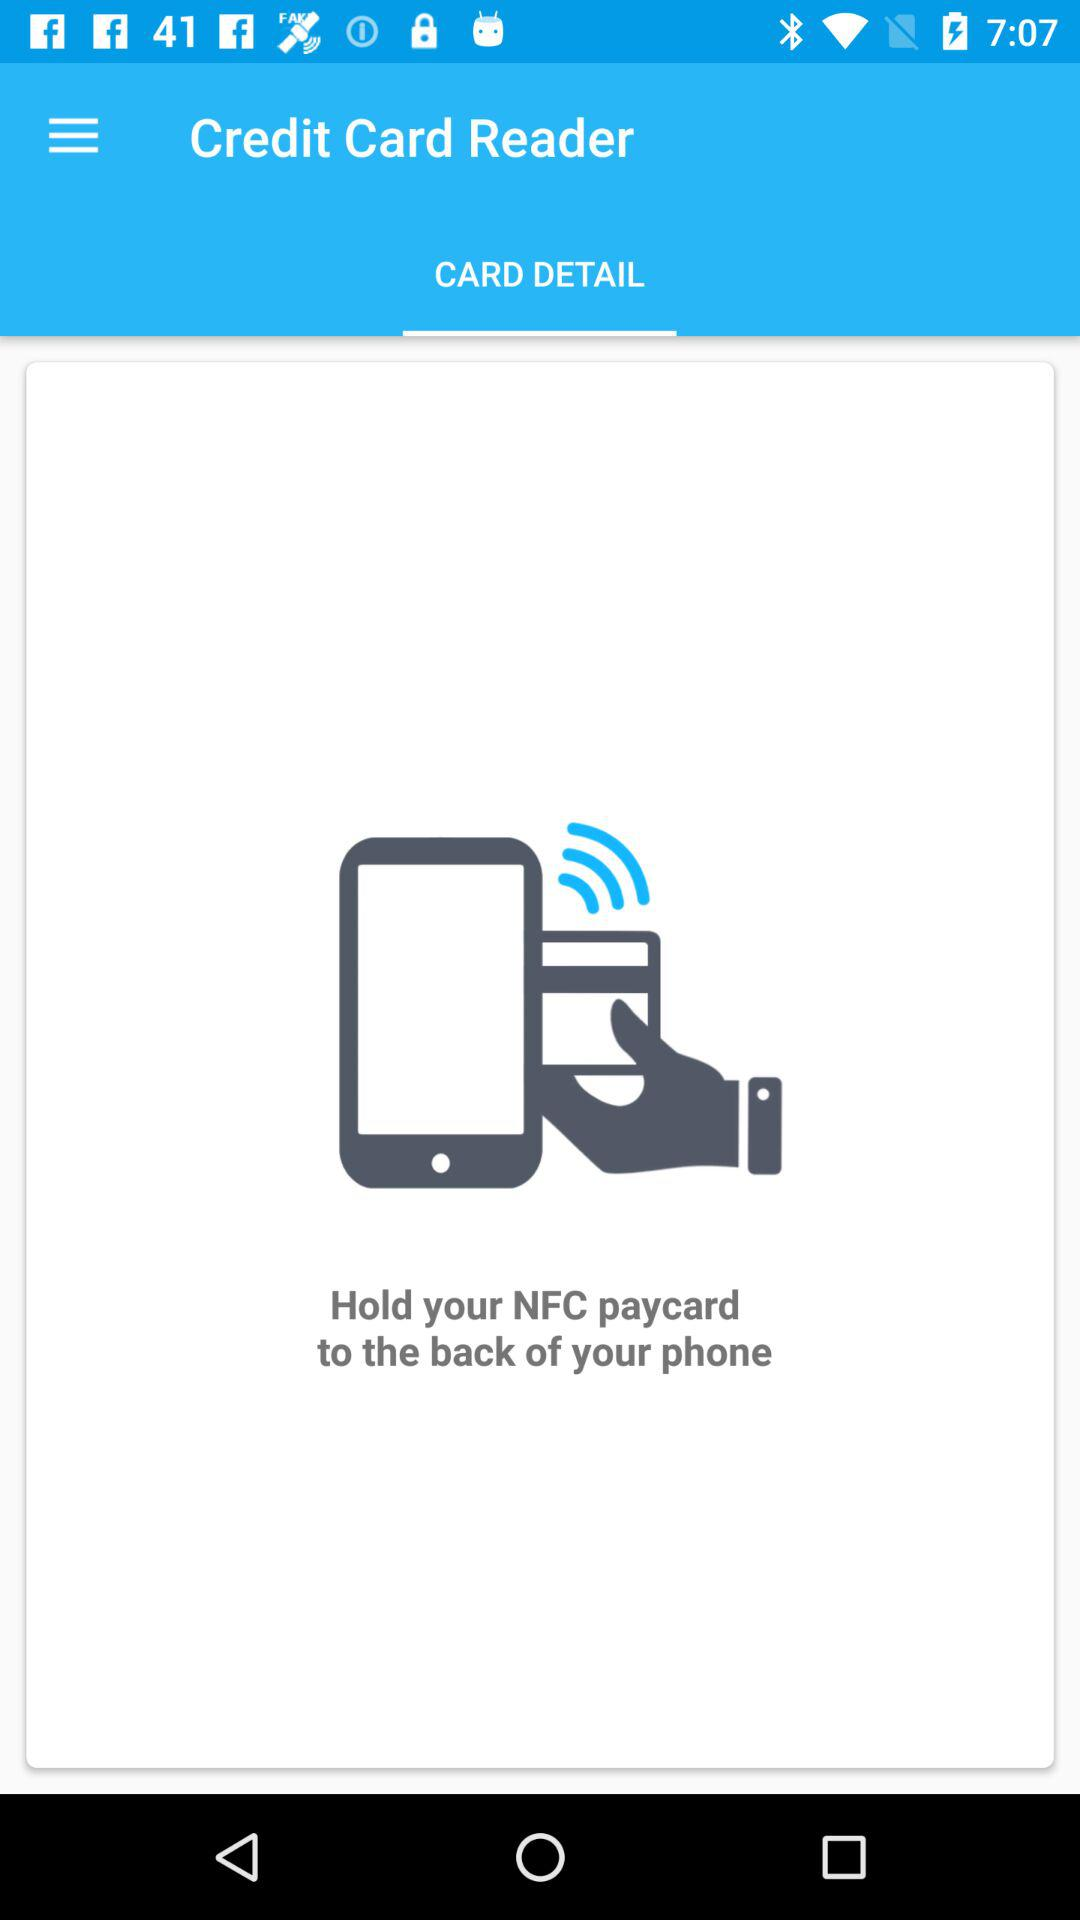What is the name of the application? The name of the application is "Credit Card Reader". 